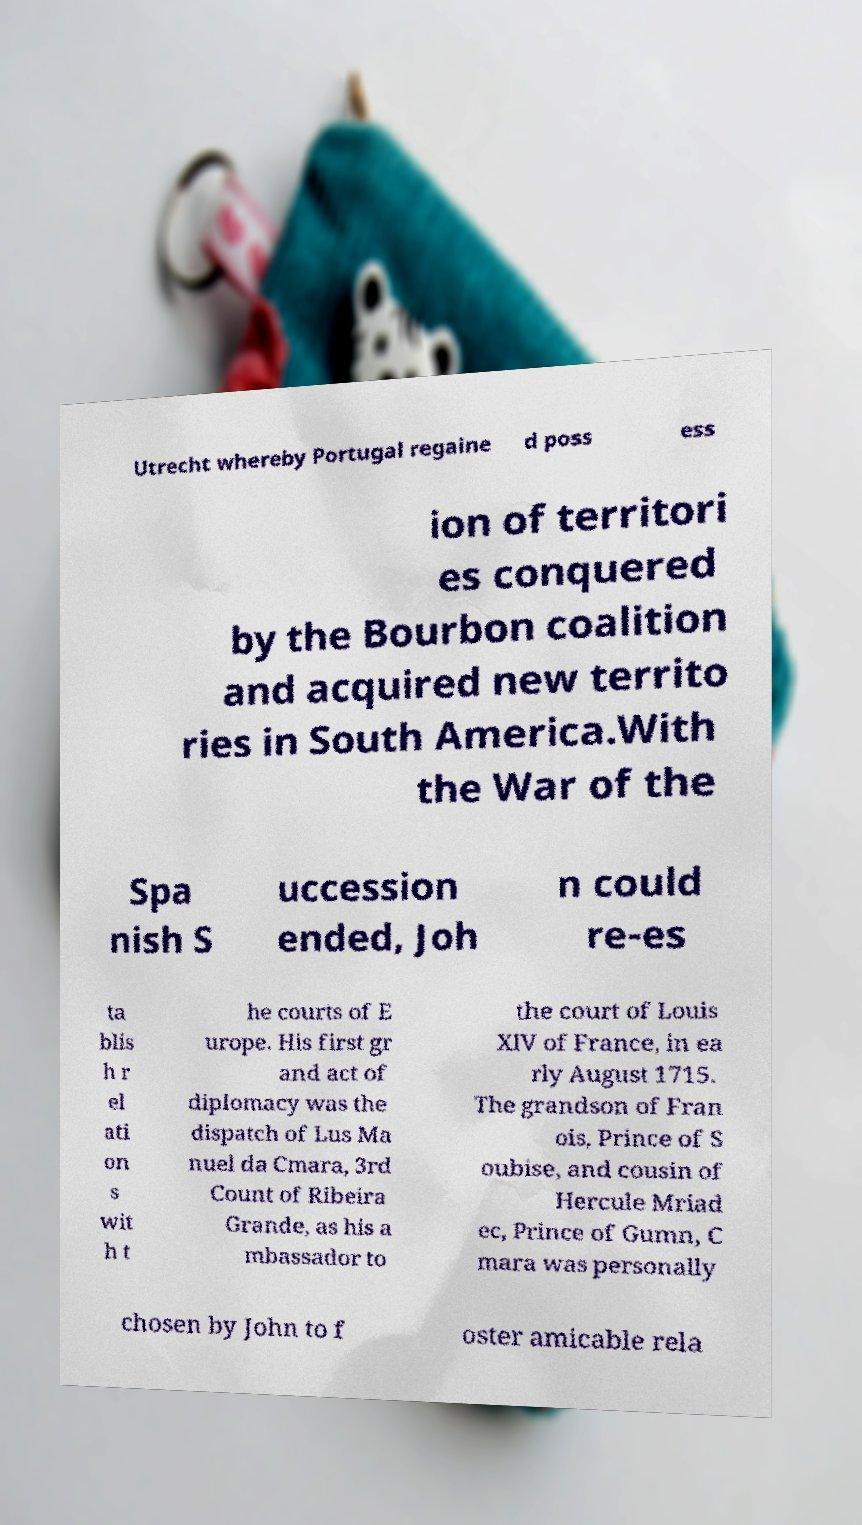What messages or text are displayed in this image? I need them in a readable, typed format. Utrecht whereby Portugal regaine d poss ess ion of territori es conquered by the Bourbon coalition and acquired new territo ries in South America.With the War of the Spa nish S uccession ended, Joh n could re-es ta blis h r el ati on s wit h t he courts of E urope. His first gr and act of diplomacy was the dispatch of Lus Ma nuel da Cmara, 3rd Count of Ribeira Grande, as his a mbassador to the court of Louis XIV of France, in ea rly August 1715. The grandson of Fran ois, Prince of S oubise, and cousin of Hercule Mriad ec, Prince of Gumn, C mara was personally chosen by John to f oster amicable rela 